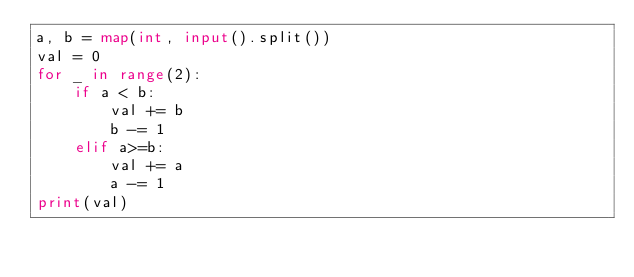Convert code to text. <code><loc_0><loc_0><loc_500><loc_500><_Python_>a, b = map(int, input().split())
val = 0
for _ in range(2):
    if a < b:
        val += b
        b -= 1
    elif a>=b:
        val += a
        a -= 1
print(val)</code> 